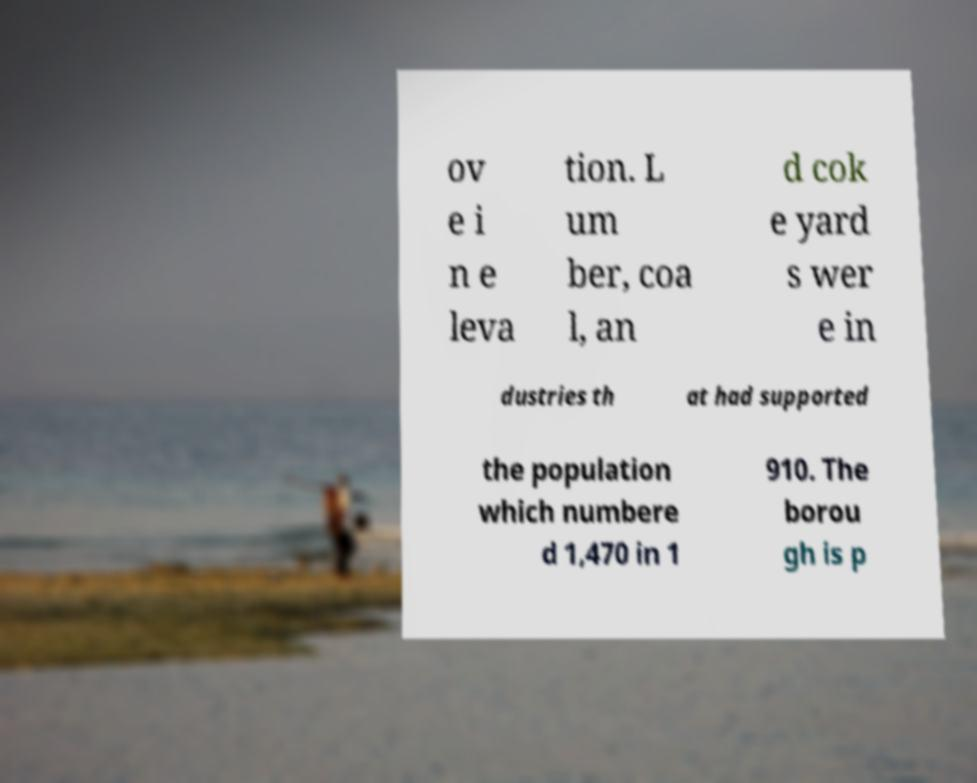For documentation purposes, I need the text within this image transcribed. Could you provide that? ov e i n e leva tion. L um ber, coa l, an d cok e yard s wer e in dustries th at had supported the population which numbere d 1,470 in 1 910. The borou gh is p 